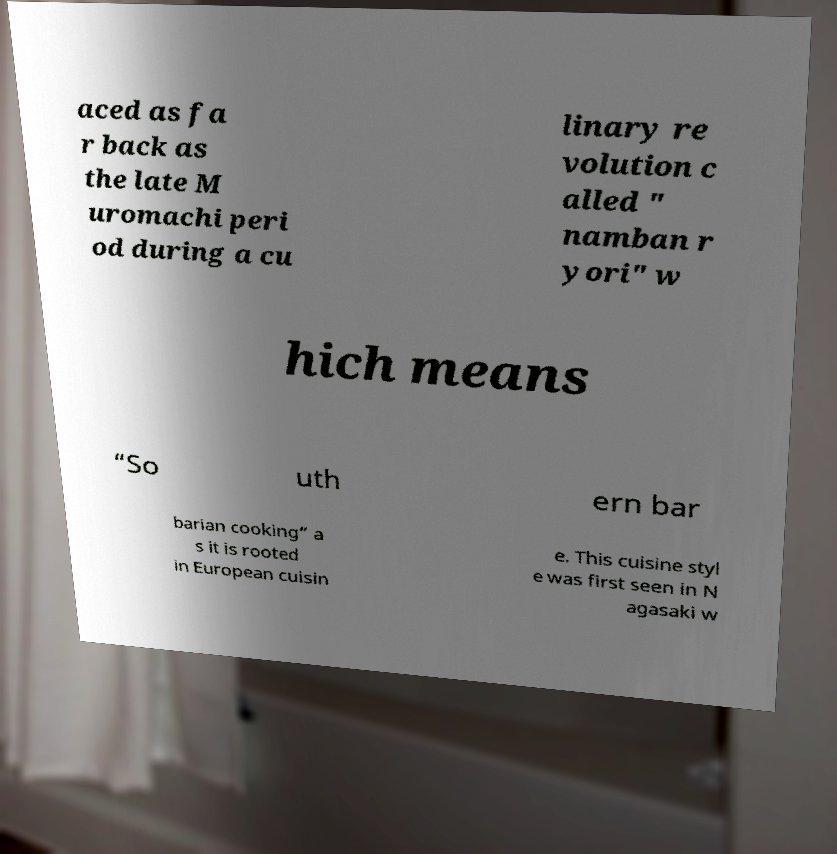Please identify and transcribe the text found in this image. aced as fa r back as the late M uromachi peri od during a cu linary re volution c alled " namban r yori" w hich means “So uth ern bar barian cooking” a s it is rooted in European cuisin e. This cuisine styl e was first seen in N agasaki w 